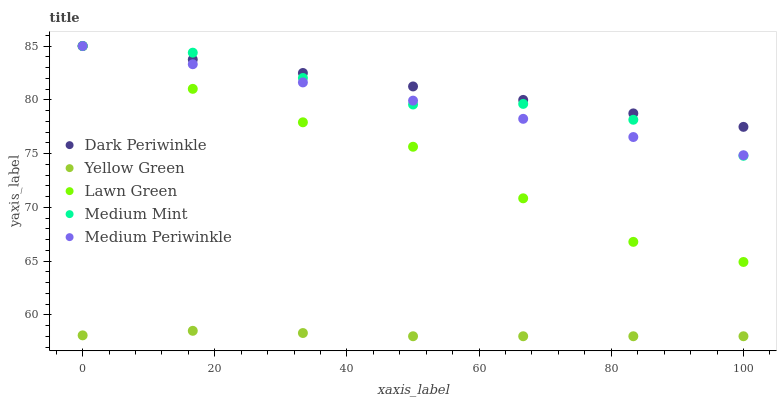Does Yellow Green have the minimum area under the curve?
Answer yes or no. Yes. Does Dark Periwinkle have the maximum area under the curve?
Answer yes or no. Yes. Does Lawn Green have the minimum area under the curve?
Answer yes or no. No. Does Lawn Green have the maximum area under the curve?
Answer yes or no. No. Is Dark Periwinkle the smoothest?
Answer yes or no. Yes. Is Medium Mint the roughest?
Answer yes or no. Yes. Is Lawn Green the smoothest?
Answer yes or no. No. Is Lawn Green the roughest?
Answer yes or no. No. Does Yellow Green have the lowest value?
Answer yes or no. Yes. Does Lawn Green have the lowest value?
Answer yes or no. No. Does Dark Periwinkle have the highest value?
Answer yes or no. Yes. Does Yellow Green have the highest value?
Answer yes or no. No. Is Yellow Green less than Dark Periwinkle?
Answer yes or no. Yes. Is Medium Periwinkle greater than Yellow Green?
Answer yes or no. Yes. Does Medium Mint intersect Dark Periwinkle?
Answer yes or no. Yes. Is Medium Mint less than Dark Periwinkle?
Answer yes or no. No. Is Medium Mint greater than Dark Periwinkle?
Answer yes or no. No. Does Yellow Green intersect Dark Periwinkle?
Answer yes or no. No. 